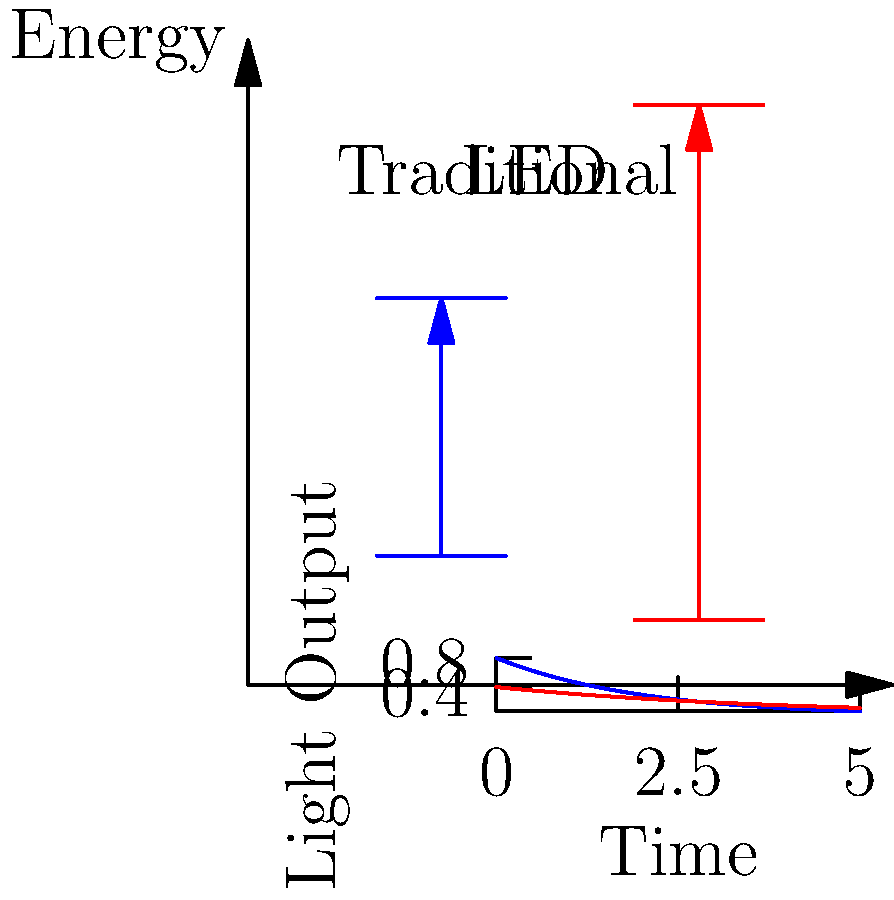As the owner of a high-tech convenience mart, you're considering upgrading your lighting system. Based on the energy level diagram and light output graph provided, which type of lighting would be more energy-efficient and cost-effective for your store in the long run, and why? To determine the most energy-efficient and cost-effective lighting option, we need to analyze the energy level diagram and light output graph:

1. Energy level diagram:
   - The LED shows a smaller energy gap between its two levels compared to the traditional bulb.
   - This indicates that LEDs require less energy to emit light.

2. Light output graph:
   - The blue line (LED) starts at a higher point and decreases more slowly over time compared to the red line (traditional bulb).
   - This suggests that LEDs produce more light output initially and maintain their brightness for a longer period.

3. Energy efficiency:
   - The smaller energy gap in LEDs means they convert more input energy into light rather than heat.
   - Traditional bulbs waste more energy as heat due to their larger energy gap.

4. Long-term cost-effectiveness:
   - Although LEDs may have a higher initial cost, their longer lifespan (as shown by the slower decrease in light output) means fewer replacements over time.
   - The higher energy efficiency of LEDs translates to lower electricity costs over the bulb's lifetime.

5. Application to a convenience mart:
   - A store typically requires constant lighting for extended periods, making energy efficiency crucial.
   - The longer lifespan of LEDs means less frequent maintenance and replacement, reducing disruption to store operations.

Given these factors, LED lighting would be more energy-efficient and cost-effective for your high-tech convenience mart in the long run. The initial investment in LED technology would be offset by reduced energy consumption and lower maintenance costs over time.
Answer: LED lighting, due to higher energy efficiency and longer lifespan. 